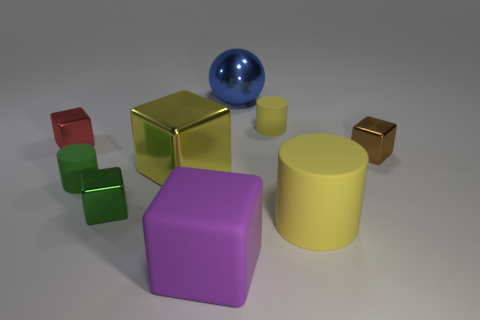Subtract all cyan cubes. Subtract all gray cylinders. How many cubes are left? 5 Subtract all blue balls. How many purple cylinders are left? 0 Add 2 small things. How many big yellows exist? 0 Subtract all small matte things. Subtract all small rubber things. How many objects are left? 5 Add 4 big cylinders. How many big cylinders are left? 5 Add 1 yellow blocks. How many yellow blocks exist? 2 Add 1 big yellow objects. How many objects exist? 10 Subtract all purple blocks. How many blocks are left? 4 Subtract all tiny cylinders. How many cylinders are left? 1 Subtract 0 blue cylinders. How many objects are left? 9 